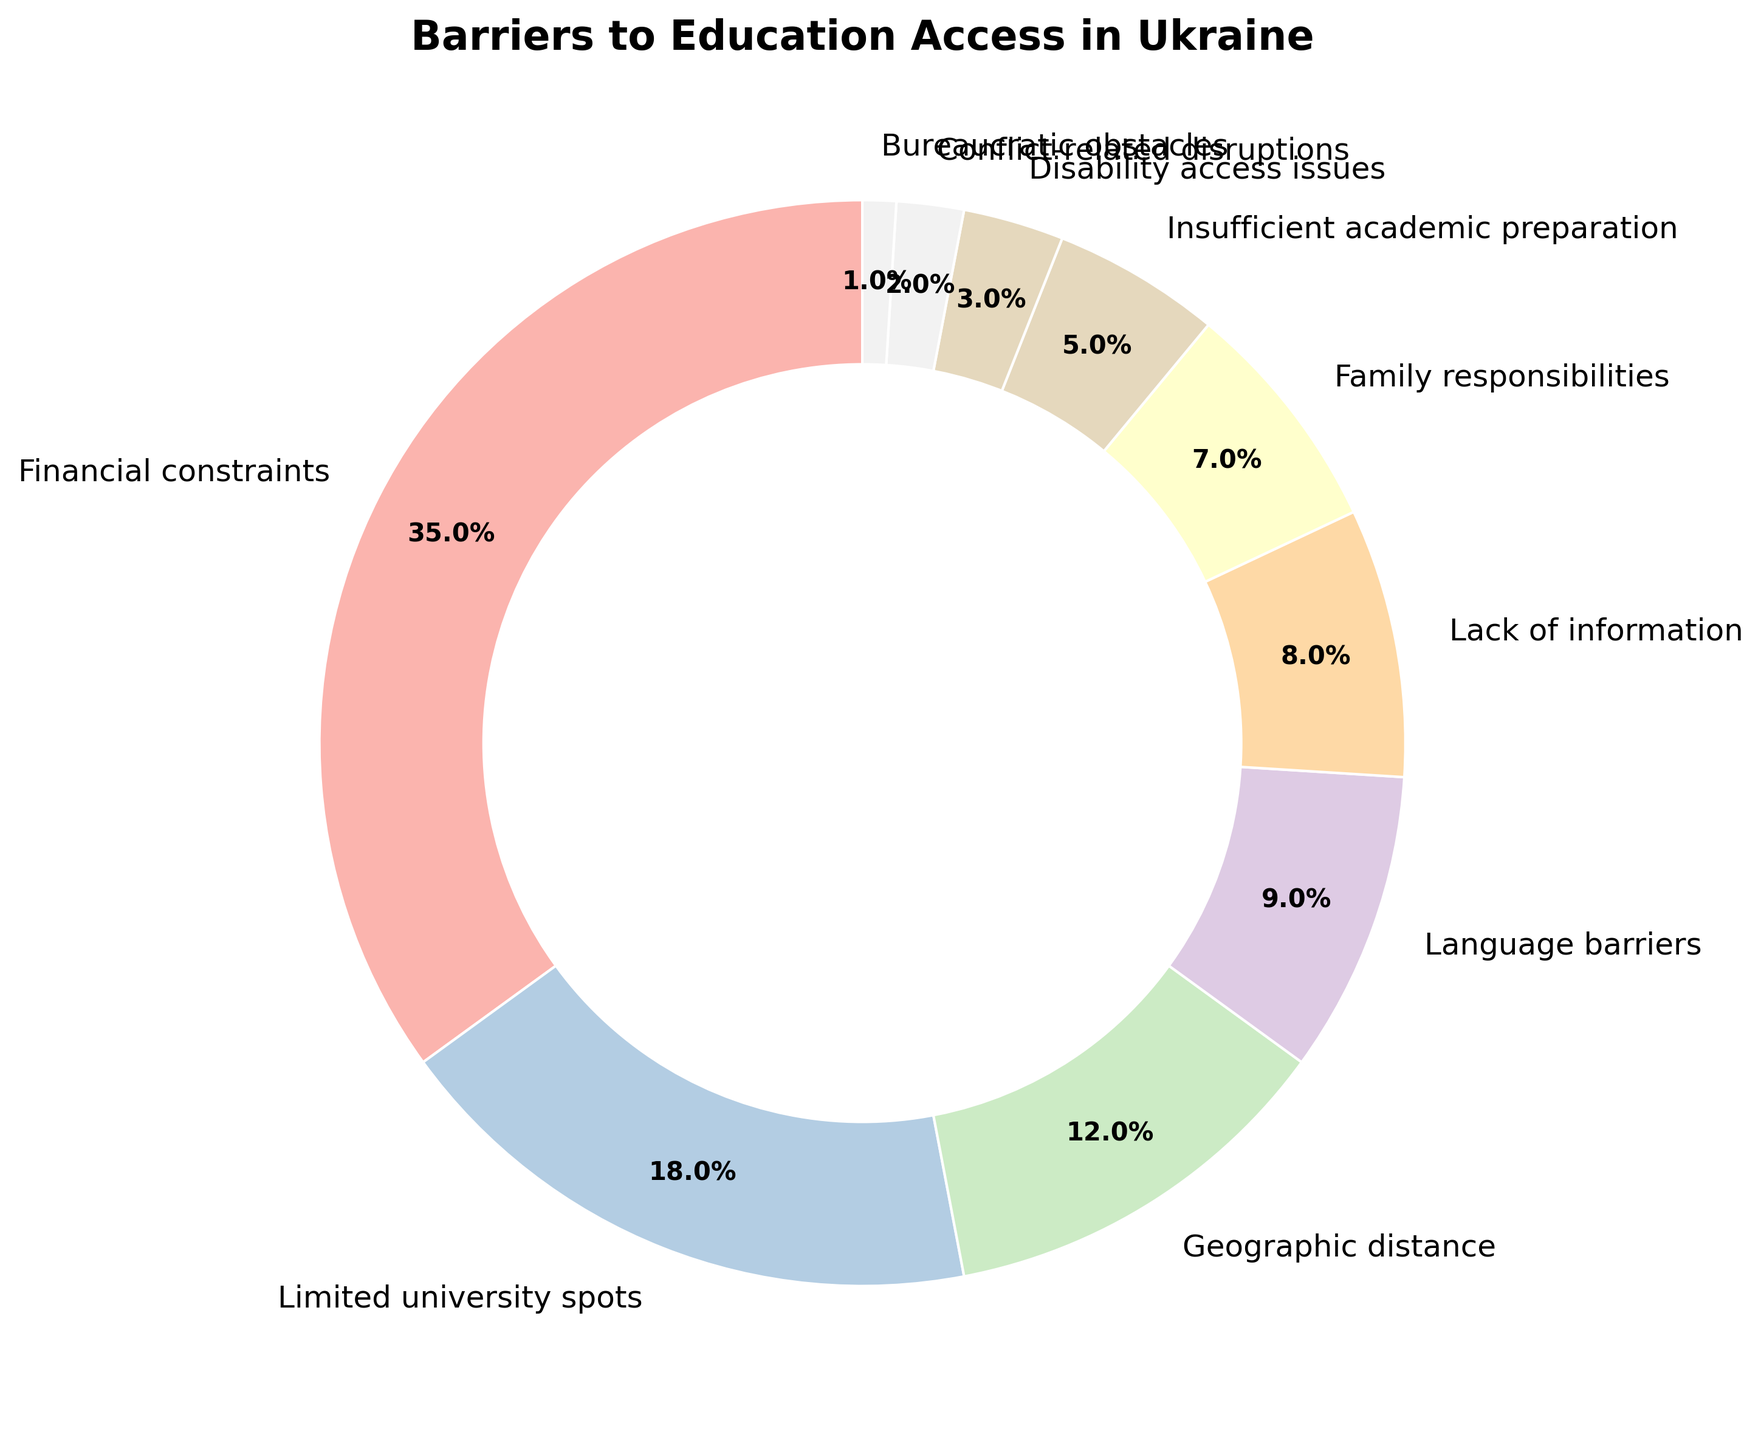Which barrier to education access has the highest percentage? The category with the largest segment in the pie chart represents the barrier with the highest percentage. From the chart, Financial constraints is the largest segment.
Answer: Financial constraints How much larger is the percentage of Financial constraints compared to Limited university spots? Subtract the percentage of Limited university spots from Financial constraints: 35% - 18% = 17%.
Answer: 17% Which barriers to education access make up less than 10% of the total each? Identify the segments from the pie chart that each account for less than 10% of the total. These are Language barriers (9%), Lack of information (8%), Family responsibilities (7%), Insufficient academic preparation (5%), Disability access issues (3%), Conflict-related disruptions (2%), and Bureaucratic obstacles (1%).
Answer: Language barriers, Lack of information, Family responsibilities, Insufficient academic preparation, Disability access issues, Conflict-related disruptions, Bureaucratic obstacles What is the combined percentage of Geographic distance and Disability access issues? Add the percentages of Geographic distance and Disability access issues: 12% + 3% = 15%.
Answer: 15% Is the percentage of Family responsibilities greater than or equal to the percentage of Conflict-related disruptions? Compare the percentages: Family responsibilities (7%) and Conflict-related disruptions (2%). 7% is greater than 2%.
Answer: Yes Which barrier has the smallest percentage? Identify the smallest segment in the pie chart. The smallest segment is Bureaucratic obstacles with 1%
Answer: Bureaucratic obstacles What is the combined percentage of barriers that contribute 20% or more to education access issues? Only Financial constraints contribute more than 20%. Its percentage is 35%. The combined percentage is 35%.
Answer: 35% Are any two barriers reported equally by the Ukrainian students? Check if any two segments of the pie chart have an equal percentage. None of the segments have the same value.
Answer: No What is the average percentage of all the barriers reported? Sum the percentages and divide by the number of categories. The total is 100% and there are 10 categories. 100% / 10 = 10%.
Answer: 10% By how much does the percentage of Limited university spots exceed the sum of Conflict-related disruptions and Bureaucratic obstacles percentages? Sum the percentages for Conflict-related disruptions and Bureaucratic obstacles: 2% + 1% = 3%. Then subtract this from the percentage of Limited university spots: 18% - 3% = 15%.
Answer: 15% 